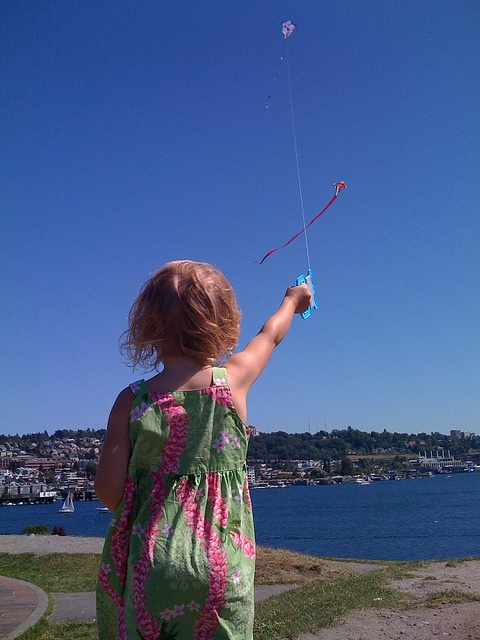Describe the objects in this image and their specific colors. I can see people in darkblue, black, maroon, gray, and lightpink tones, kite in darkblue, blue, purple, navy, and gray tones, kite in darkblue, blue, and violet tones, boat in darkblue, gray, darkgray, and navy tones, and boat in darkblue, black, and gray tones in this image. 